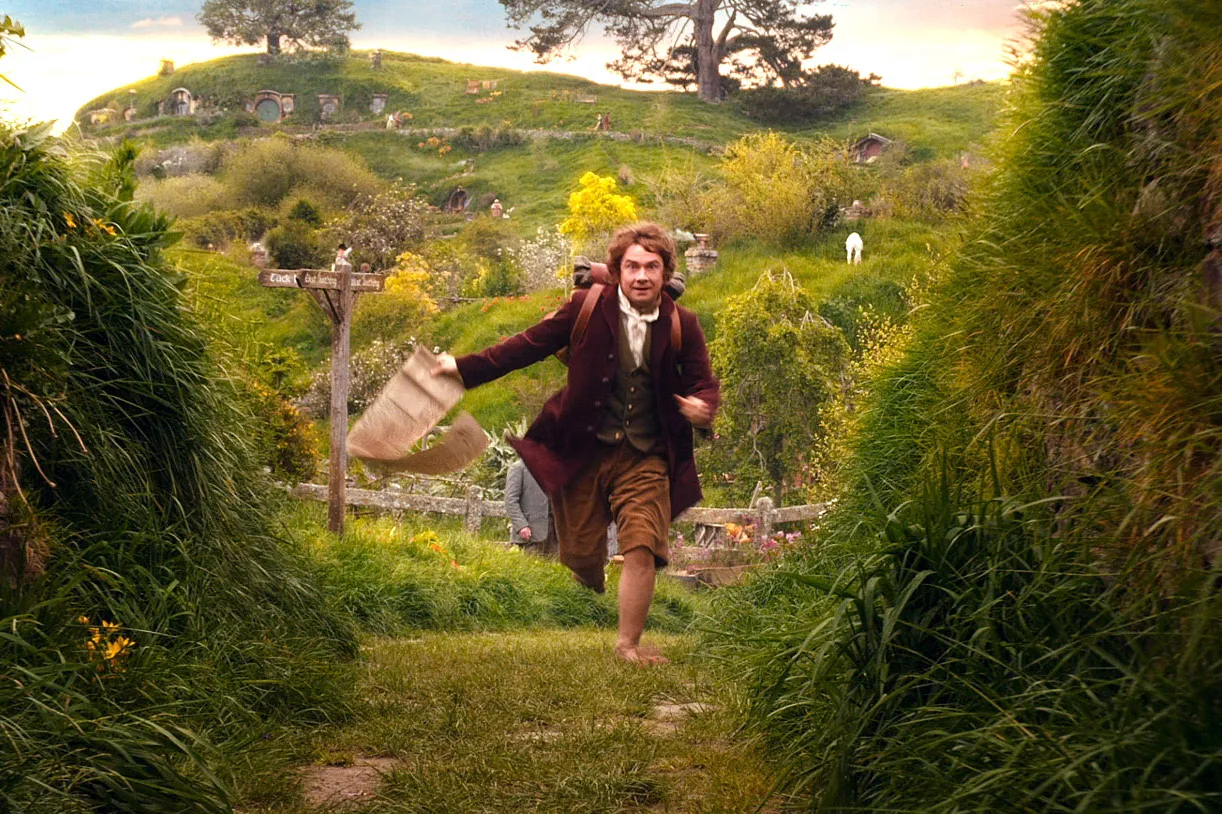What might be the reason for the character's hurried action in this scene? The character appears to be in a rush possibly due to an urgent quest or adventure. His frantic gait and the determined expression suggest he may be running either to or from something of great importance, which is typical in stories involving unexpected journeys or missions. 